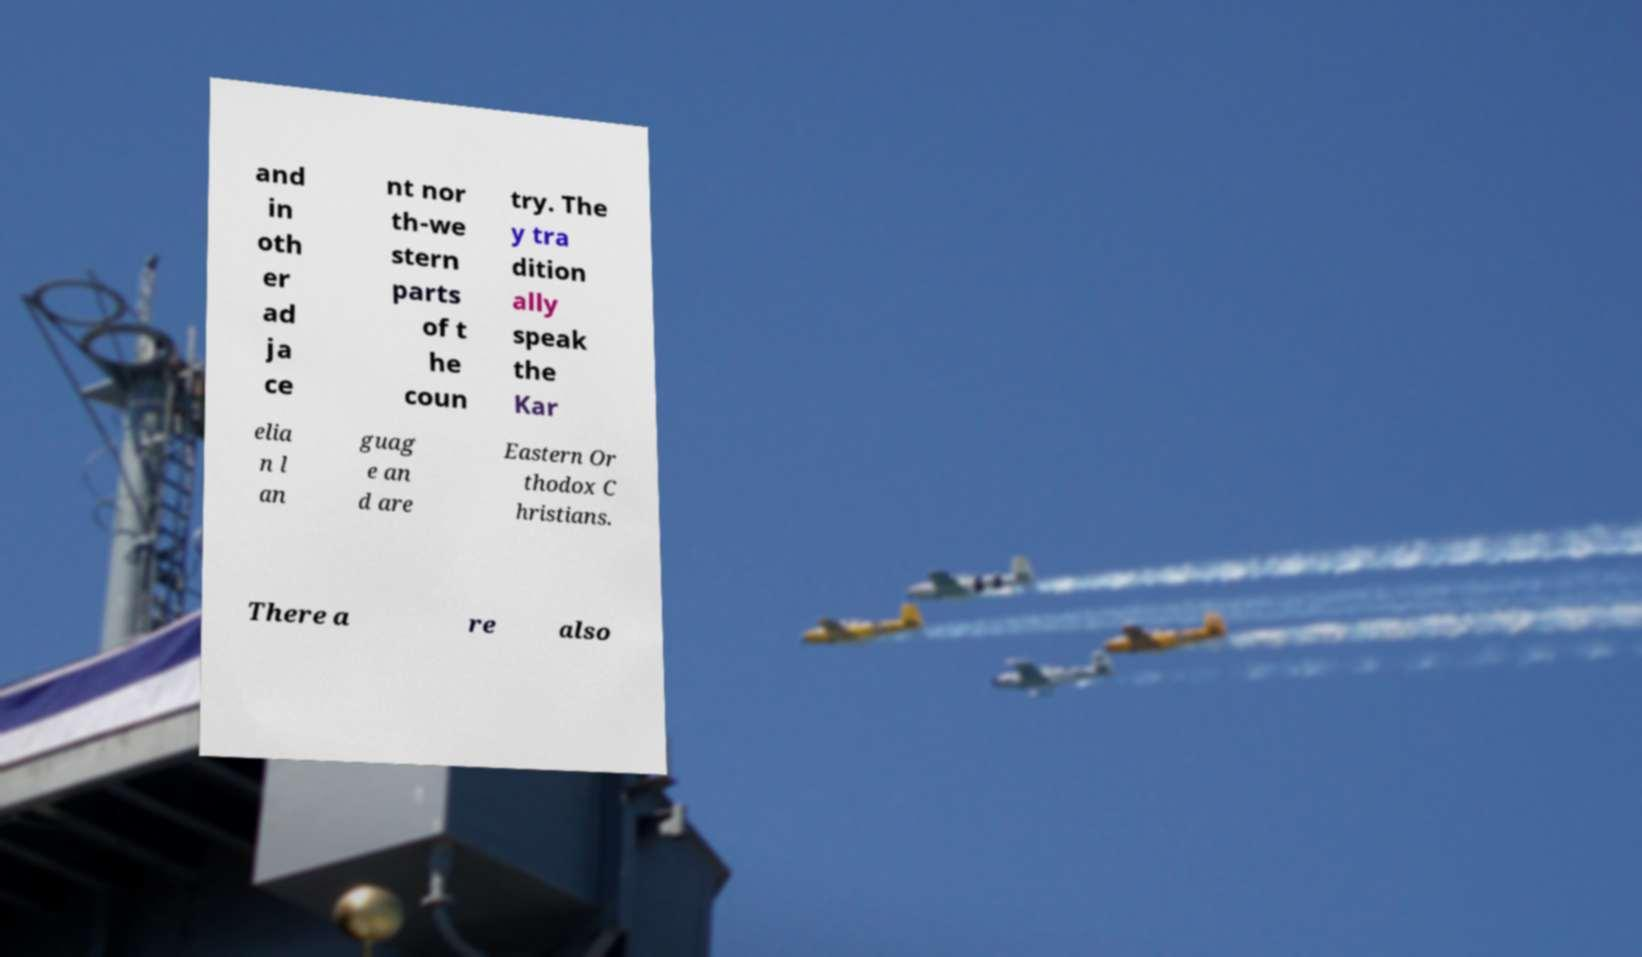Please identify and transcribe the text found in this image. and in oth er ad ja ce nt nor th-we stern parts of t he coun try. The y tra dition ally speak the Kar elia n l an guag e an d are Eastern Or thodox C hristians. There a re also 